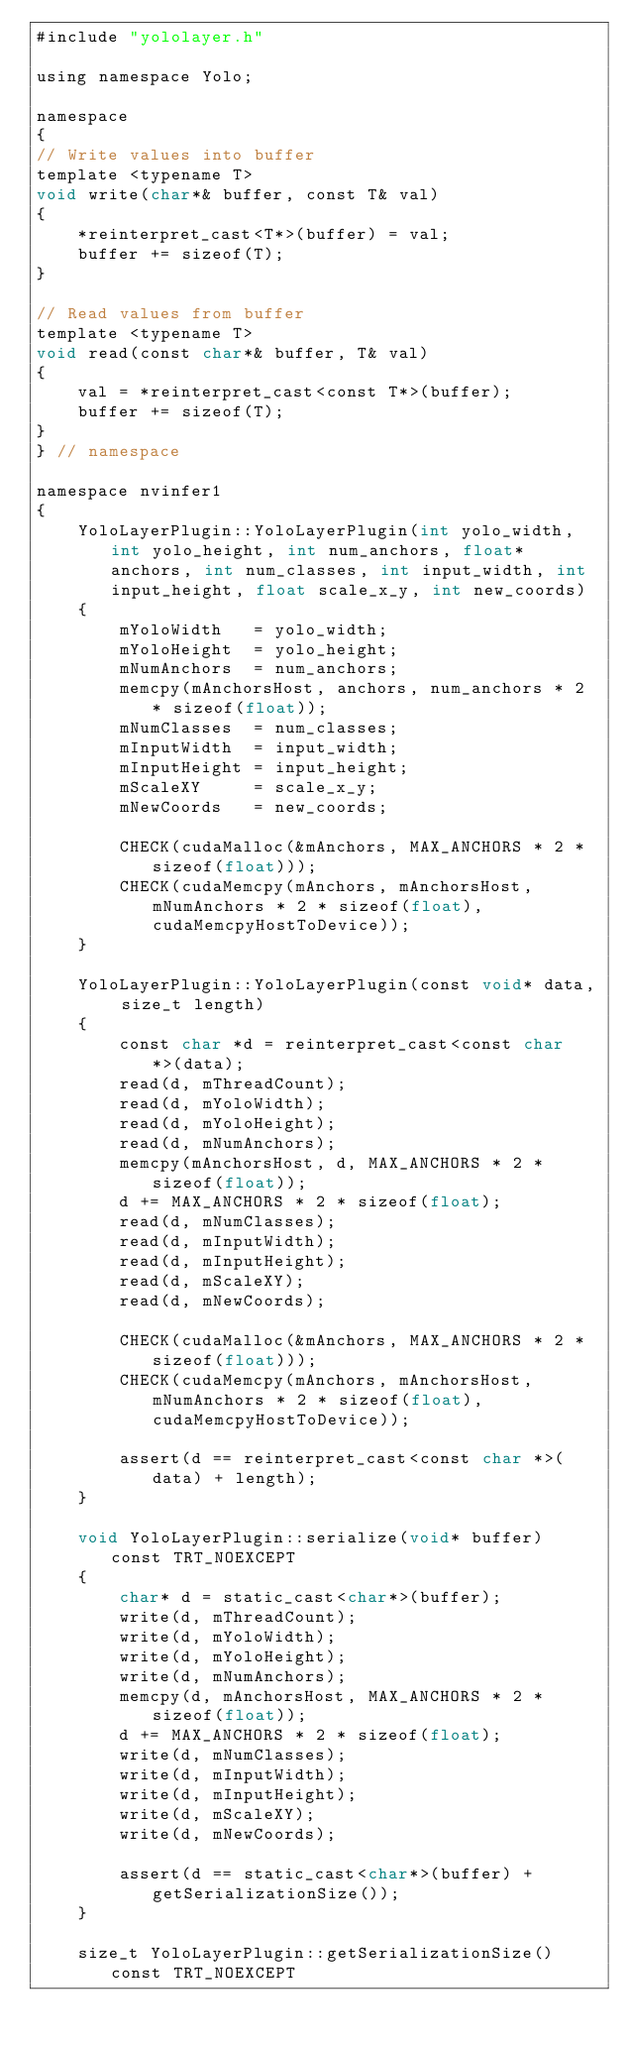Convert code to text. <code><loc_0><loc_0><loc_500><loc_500><_Cuda_>#include "yololayer.h"

using namespace Yolo;

namespace
{
// Write values into buffer
template <typename T>
void write(char*& buffer, const T& val)
{
    *reinterpret_cast<T*>(buffer) = val;
    buffer += sizeof(T);
}

// Read values from buffer
template <typename T>
void read(const char*& buffer, T& val)
{
    val = *reinterpret_cast<const T*>(buffer);
    buffer += sizeof(T);
}
} // namespace

namespace nvinfer1
{
    YoloLayerPlugin::YoloLayerPlugin(int yolo_width, int yolo_height, int num_anchors, float* anchors, int num_classes, int input_width, int input_height, float scale_x_y, int new_coords)
    {
        mYoloWidth   = yolo_width;
        mYoloHeight  = yolo_height;
        mNumAnchors  = num_anchors;
        memcpy(mAnchorsHost, anchors, num_anchors * 2 * sizeof(float));
        mNumClasses  = num_classes;
        mInputWidth  = input_width;
        mInputHeight = input_height;
        mScaleXY     = scale_x_y;
        mNewCoords   = new_coords;

        CHECK(cudaMalloc(&mAnchors, MAX_ANCHORS * 2 * sizeof(float)));
        CHECK(cudaMemcpy(mAnchors, mAnchorsHost, mNumAnchors * 2 * sizeof(float), cudaMemcpyHostToDevice));
    }

    YoloLayerPlugin::YoloLayerPlugin(const void* data, size_t length)
    {
        const char *d = reinterpret_cast<const char *>(data);
        read(d, mThreadCount);
        read(d, mYoloWidth);
        read(d, mYoloHeight);
        read(d, mNumAnchors);
        memcpy(mAnchorsHost, d, MAX_ANCHORS * 2 * sizeof(float));
        d += MAX_ANCHORS * 2 * sizeof(float);
        read(d, mNumClasses);
        read(d, mInputWidth);
        read(d, mInputHeight);
        read(d, mScaleXY);
        read(d, mNewCoords);

        CHECK(cudaMalloc(&mAnchors, MAX_ANCHORS * 2 * sizeof(float)));
        CHECK(cudaMemcpy(mAnchors, mAnchorsHost, mNumAnchors * 2 * sizeof(float), cudaMemcpyHostToDevice));

        assert(d == reinterpret_cast<const char *>(data) + length);
    }

    void YoloLayerPlugin::serialize(void* buffer) const TRT_NOEXCEPT
    {
        char* d = static_cast<char*>(buffer);
        write(d, mThreadCount);
        write(d, mYoloWidth);
        write(d, mYoloHeight);
        write(d, mNumAnchors);
        memcpy(d, mAnchorsHost, MAX_ANCHORS * 2 * sizeof(float));
        d += MAX_ANCHORS * 2 * sizeof(float);
        write(d, mNumClasses);
        write(d, mInputWidth);
        write(d, mInputHeight);
        write(d, mScaleXY);
        write(d, mNewCoords);

        assert(d == static_cast<char*>(buffer) + getSerializationSize());
    }

    size_t YoloLayerPlugin::getSerializationSize() const TRT_NOEXCEPT</code> 